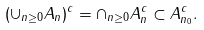Convert formula to latex. <formula><loc_0><loc_0><loc_500><loc_500>( \cup _ { n \geq 0 } A _ { n } ) ^ { c } = \cap _ { n \geq 0 } A _ { n } ^ { c } \subset A _ { n _ { 0 } } ^ { c } .</formula> 